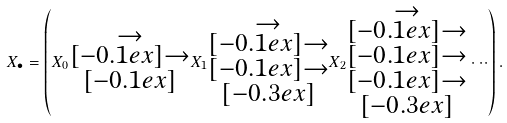Convert formula to latex. <formula><loc_0><loc_0><loc_500><loc_500>X _ { \bullet } = \left ( X _ { 0 } \substack { \rightarrow \\ [ - 0 . 1 e x ] \rightarrow \\ [ - 0 . 1 e x ] } X _ { 1 } \substack { \rightarrow \\ [ - 0 . 1 e x ] \rightarrow \\ [ - 0 . 1 e x ] \rightarrow \\ [ - 0 . 3 e x ] } X _ { 2 } \substack { \rightarrow \\ [ - 0 . 1 e x ] \rightarrow \\ [ - 0 . 1 e x ] \rightarrow \\ [ - 0 . 1 e x ] \rightarrow \\ [ - 0 . 3 e x ] } \cdot \cdot \cdot \right ) .</formula> 